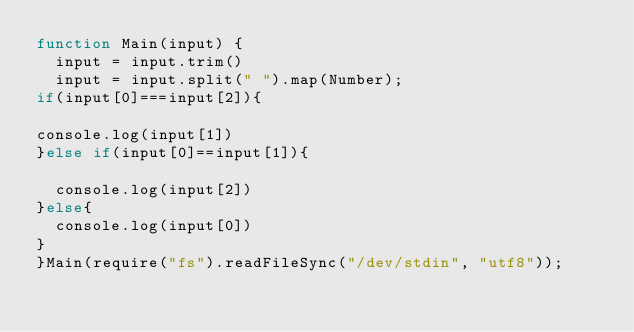Convert code to text. <code><loc_0><loc_0><loc_500><loc_500><_JavaScript_>function Main(input) {
  input = input.trim()
  input = input.split(" ").map(Number);
if(input[0]===input[2]){

console.log(input[1])
}else if(input[0]==input[1]){

  console.log(input[2])
}else{
  console.log(input[0])
}
}Main(require("fs").readFileSync("/dev/stdin", "utf8"));
</code> 